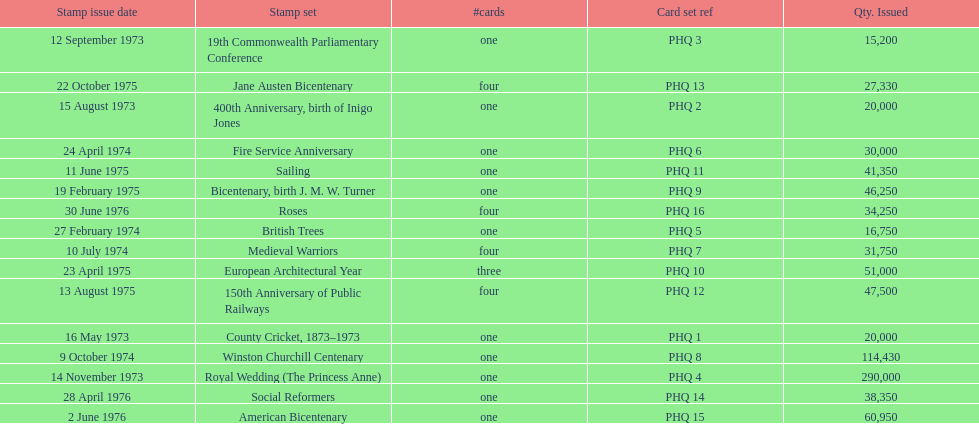How many stamp sets were released in the year 1975? 5. 